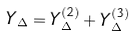Convert formula to latex. <formula><loc_0><loc_0><loc_500><loc_500>Y _ { \Delta } = Y _ { \Delta } ^ { ( 2 ) } + Y _ { \Delta } ^ { ( 3 ) }</formula> 